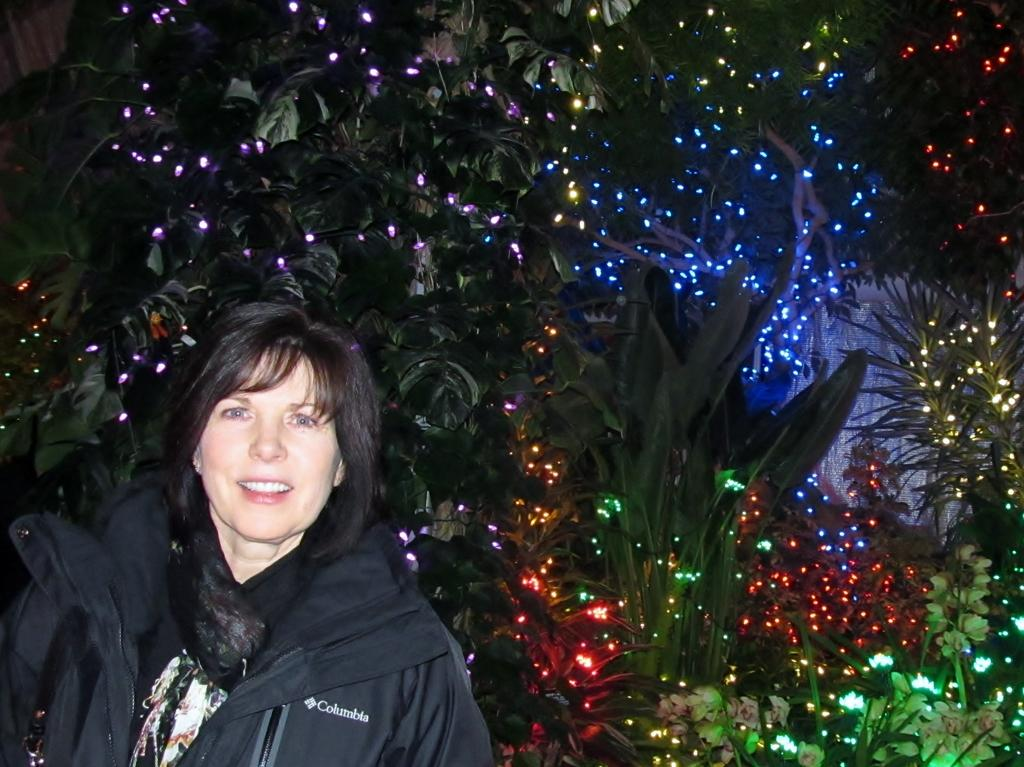Who is present in the image? There is a woman in the image. What is the woman's expression? The woman is smiling. What can be seen in the background of the image? There are plants and trees with lights in the background of the image. What is the mass of the chain hanging from the tree in the image? There is no chain hanging from the tree in the image. 